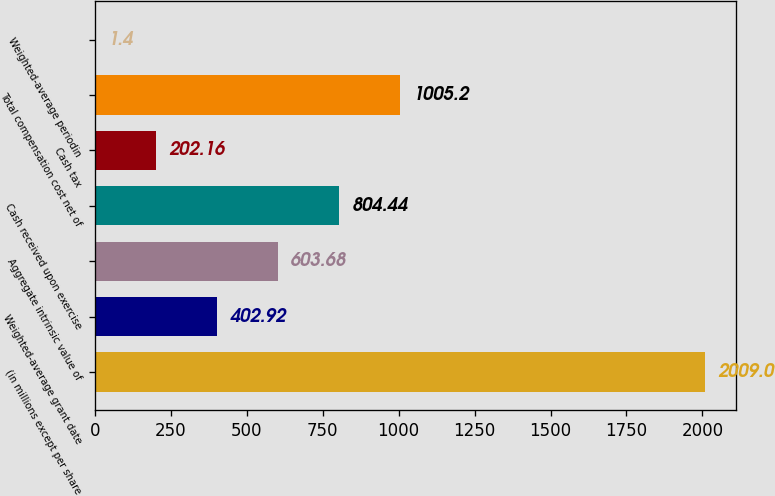Convert chart to OTSL. <chart><loc_0><loc_0><loc_500><loc_500><bar_chart><fcel>(in millions except per share<fcel>Weighted-average grant date<fcel>Aggregate intrinsic value of<fcel>Cash received upon exercise<fcel>Cash tax<fcel>Total compensation cost net of<fcel>Weighted-average periodin<nl><fcel>2009<fcel>402.92<fcel>603.68<fcel>804.44<fcel>202.16<fcel>1005.2<fcel>1.4<nl></chart> 